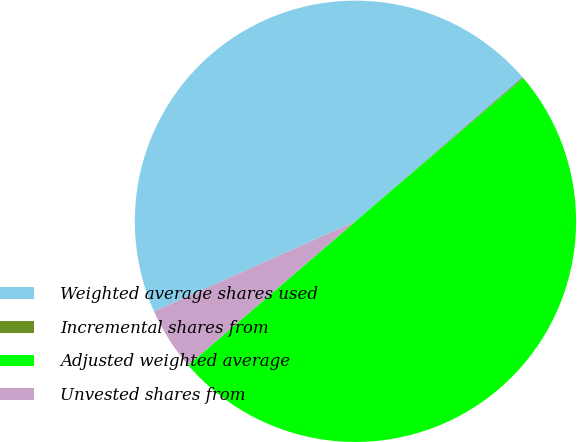Convert chart. <chart><loc_0><loc_0><loc_500><loc_500><pie_chart><fcel>Weighted average shares used<fcel>Incremental shares from<fcel>Adjusted weighted average<fcel>Unvested shares from<nl><fcel>45.39%<fcel>0.08%<fcel>49.92%<fcel>4.61%<nl></chart> 